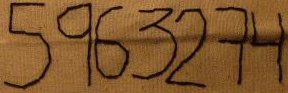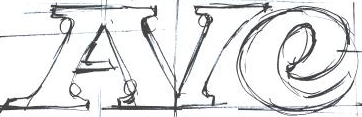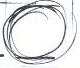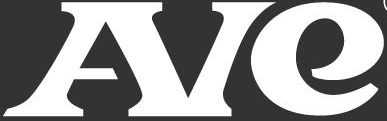Read the text from these images in sequence, separated by a semicolon. 5963274; AIe; .; AIe 